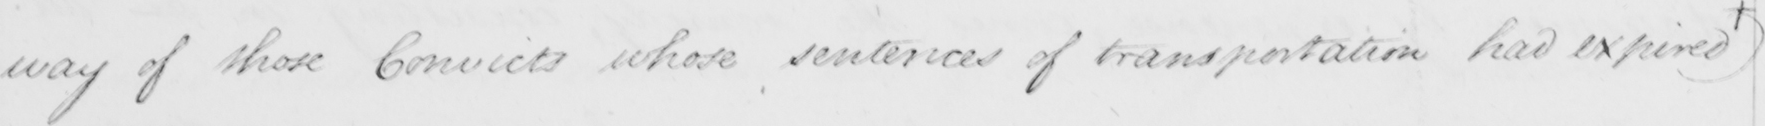Please provide the text content of this handwritten line. way of those Convicts whose sentences of transportation had expired + 